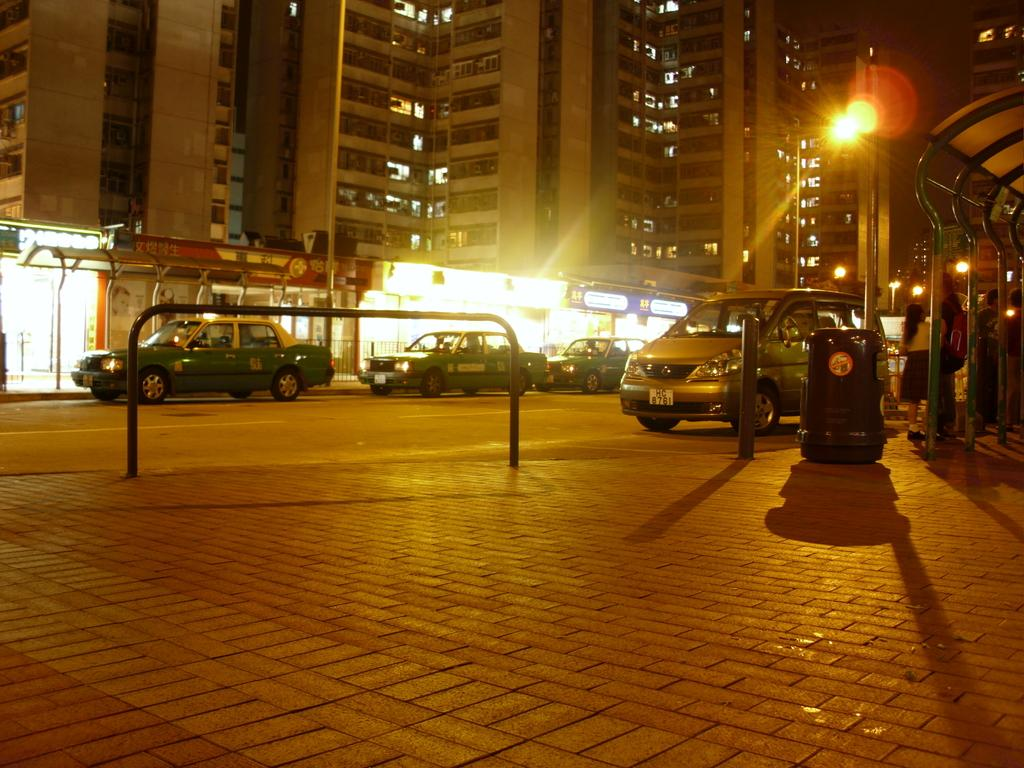What type of structures can be seen in the image? There are many buildings in the image. What type of vehicles are on the road in the image? Cars are visible on the road in the image. What is the source of light in the image? There is a light in the image. What is the tall, vertical object in the image? There is a pole in the image. What type of transportation infrastructure is present in the image? There is a bus stop in the image. What is visible in the background of the image? The sky is visible in the image. What type of key is used to unlock the structure in the image? There is no structure or key present in the image. What type of acoustics can be heard in the image? There is no sound or acoustics present in the image, as it is a still image. 